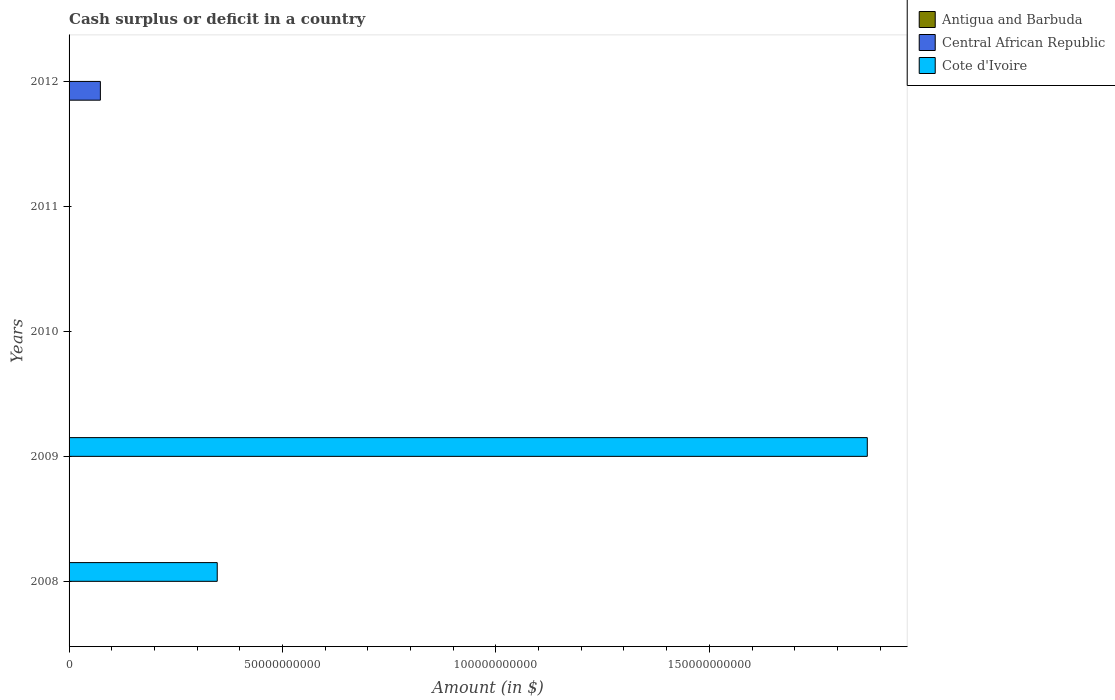How many different coloured bars are there?
Ensure brevity in your answer.  2. How many bars are there on the 1st tick from the top?
Your answer should be compact. 1. What is the label of the 3rd group of bars from the top?
Offer a very short reply. 2010. In how many cases, is the number of bars for a given year not equal to the number of legend labels?
Your answer should be compact. 5. Across all years, what is the maximum amount of cash surplus or deficit in Central African Republic?
Provide a succinct answer. 7.33e+09. What is the difference between the amount of cash surplus or deficit in Central African Republic in 2009 and the amount of cash surplus or deficit in Cote d'Ivoire in 2012?
Ensure brevity in your answer.  0. What is the average amount of cash surplus or deficit in Cote d'Ivoire per year?
Keep it short and to the point. 4.43e+1. What is the difference between the highest and the lowest amount of cash surplus or deficit in Central African Republic?
Your answer should be compact. 7.33e+09. Are all the bars in the graph horizontal?
Give a very brief answer. Yes. How many years are there in the graph?
Make the answer very short. 5. Does the graph contain any zero values?
Provide a short and direct response. Yes. Does the graph contain grids?
Your response must be concise. No. How many legend labels are there?
Your answer should be very brief. 3. How are the legend labels stacked?
Make the answer very short. Vertical. What is the title of the graph?
Provide a short and direct response. Cash surplus or deficit in a country. What is the label or title of the X-axis?
Offer a very short reply. Amount (in $). What is the Amount (in $) of Central African Republic in 2008?
Provide a short and direct response. 0. What is the Amount (in $) of Cote d'Ivoire in 2008?
Make the answer very short. 3.47e+1. What is the Amount (in $) of Antigua and Barbuda in 2009?
Give a very brief answer. 0. What is the Amount (in $) in Central African Republic in 2009?
Ensure brevity in your answer.  0. What is the Amount (in $) of Cote d'Ivoire in 2009?
Provide a succinct answer. 1.87e+11. What is the Amount (in $) in Central African Republic in 2010?
Your answer should be very brief. 0. What is the Amount (in $) in Central African Republic in 2012?
Offer a terse response. 7.33e+09. Across all years, what is the maximum Amount (in $) in Central African Republic?
Ensure brevity in your answer.  7.33e+09. Across all years, what is the maximum Amount (in $) in Cote d'Ivoire?
Your answer should be very brief. 1.87e+11. Across all years, what is the minimum Amount (in $) of Central African Republic?
Your answer should be compact. 0. What is the total Amount (in $) in Central African Republic in the graph?
Offer a terse response. 7.33e+09. What is the total Amount (in $) in Cote d'Ivoire in the graph?
Offer a very short reply. 2.22e+11. What is the difference between the Amount (in $) of Cote d'Ivoire in 2008 and that in 2009?
Provide a short and direct response. -1.52e+11. What is the average Amount (in $) in Antigua and Barbuda per year?
Keep it short and to the point. 0. What is the average Amount (in $) in Central African Republic per year?
Keep it short and to the point. 1.47e+09. What is the average Amount (in $) of Cote d'Ivoire per year?
Offer a very short reply. 4.43e+1. What is the ratio of the Amount (in $) of Cote d'Ivoire in 2008 to that in 2009?
Offer a terse response. 0.19. What is the difference between the highest and the lowest Amount (in $) of Central African Republic?
Offer a terse response. 7.33e+09. What is the difference between the highest and the lowest Amount (in $) in Cote d'Ivoire?
Your response must be concise. 1.87e+11. 